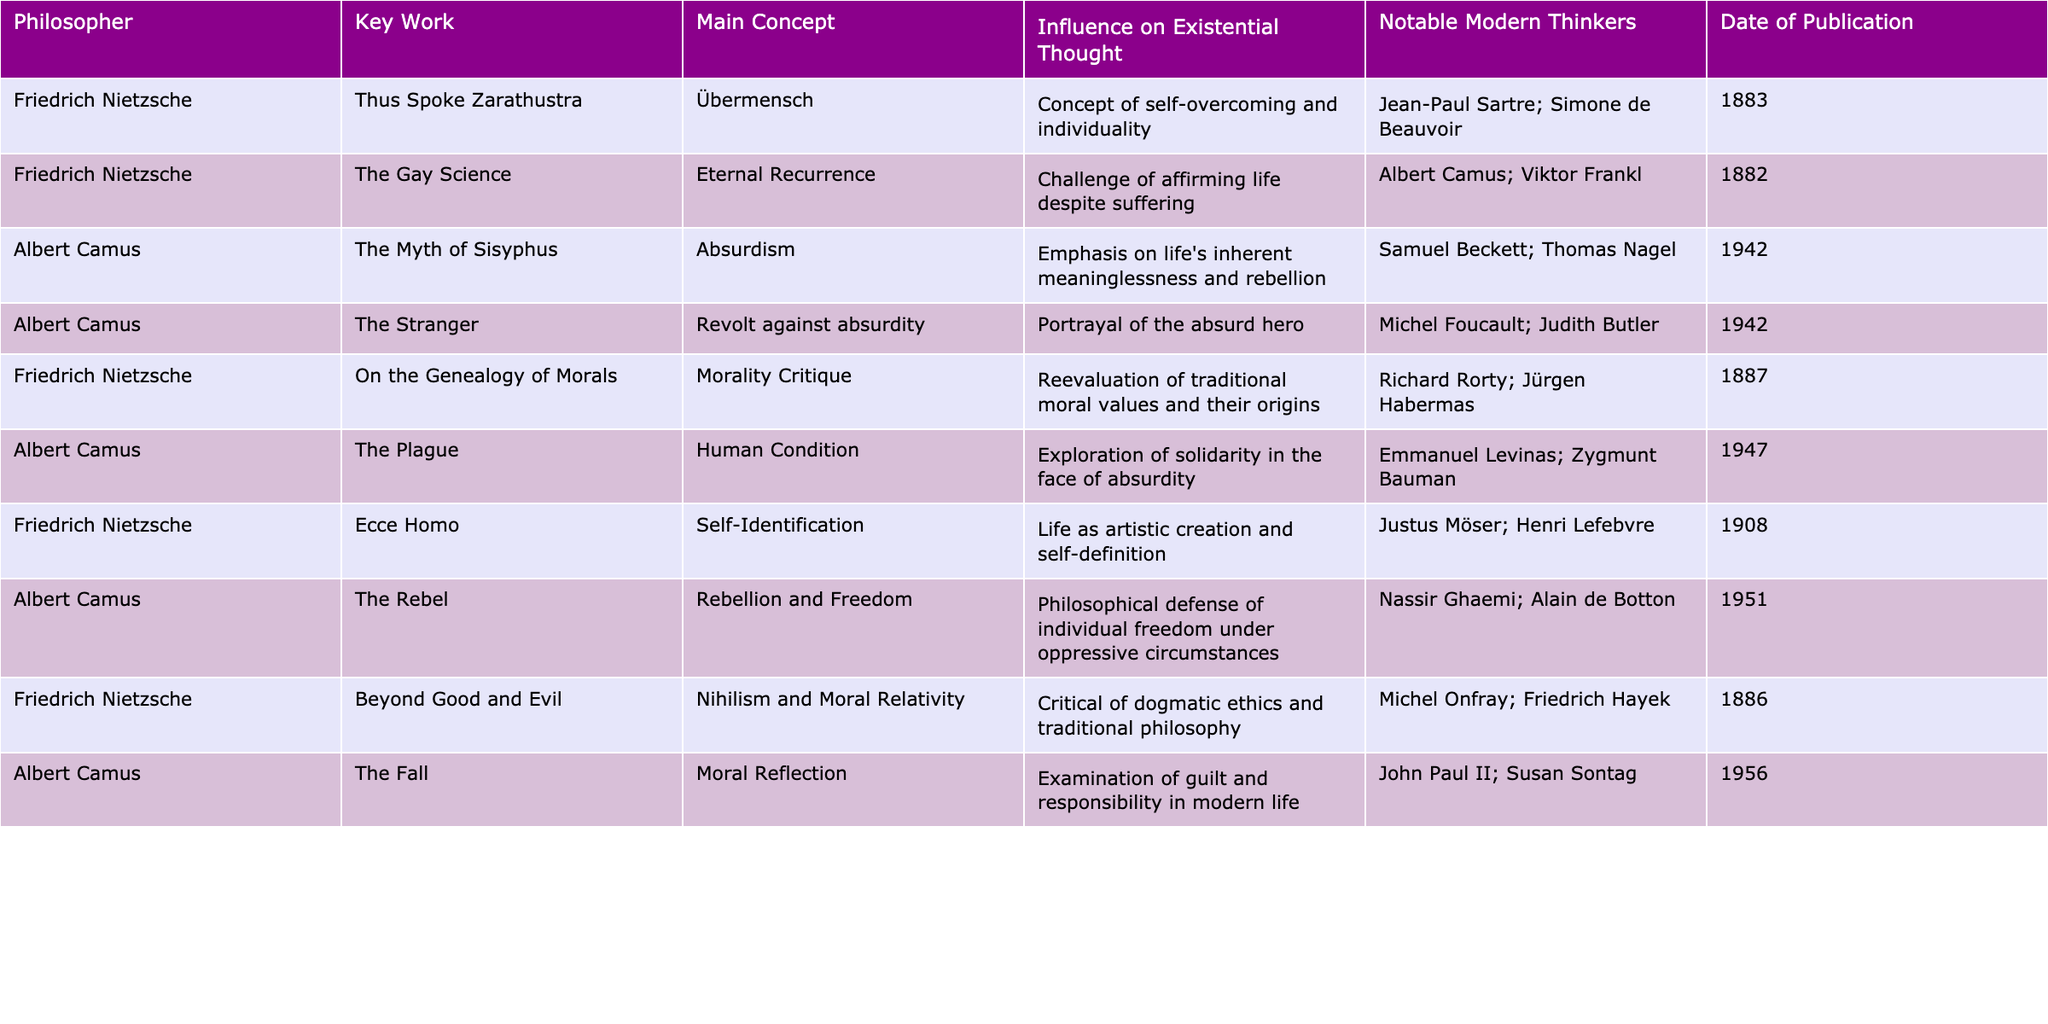What key work of Nietzsche discusses the concept of the Übermensch? According to the table, the key work of Nietzsche that discusses the concept of the Übermensch is "Thus Spoke Zarathustra."
Answer: Thus Spoke Zarathustra Which notable modern thinker is influenced by Nietzsche's concept of Eternal Recurrence? The table indicates that Albert Camus is a notable modern thinker influenced by Nietzsche's concept of Eternal Recurrence from "The Gay Science."
Answer: Albert Camus How many notable thinkers are associated with Camus' "The Myth of Sisyphus"? The table shows that Camus' "The Myth of Sisyphus" influences two notable modern thinkers: Samuel Beckett and Thomas Nagel.
Answer: 2 In which year was Nietzsche's "On the Genealogy of Morals" published? From the table, it can be seen that Nietzsche's "On the Genealogy of Morals" was published in 1887.
Answer: 1887 Which philosopher's works include themes of rebellion and freedom? The table states that Albert Camus' works, specifically "The Rebel," include themes of rebellion and freedom.
Answer: Albert Camus What are the main concepts of Camus' "The Stranger"? The table indicates that the main concept of Camus' "The Stranger" is the revolt against absurdity.
Answer: Revolt against absurdity Which philosopher's works are related to the exploration of the human condition in the face of absurdity? The table suggests that Albert Camus' "The Plague" explores the human condition in the face of absurdity.
Answer: Albert Camus Compare the number of notable modern thinkers influenced by Nietzsche and Camus. Nietzsche has four notable modern thinkers (Sartre, Beauvoir, Frankl, Onfray) compared to Camus’ five (Beckett, Nagel, Foucault, Butler, Ghaemi, and de Botton).
Answer: Camus has more thinkers Which work of Nietzsche is focused on the critique of morality? The table lists "On the Genealogy of Morals" as Nietzsche's work focused on the critique of morality.
Answer: On the Genealogy of Morals Identify the shared theme of the influence on existential thought between Nietzsche's "Beyond Good and Evil" and Camus' "The Myth of Sisyphus." Both Nietzsche's "Beyond Good and Evil" and Camus' "The Myth of Sisyphus" influence thinkers through challenges to traditional philosophical views, with Nietzsche focusing on nihilism and moral relativity, while Camus emphasizes life's inherent meaninglessness.
Answer: Challenges to traditional views What is the relationship between the publication dates of Nietzsche's and Camus' works listed in the table? There is a gap in the publication dates: Nietzsche's works range from 1882 to 1908, while Camus' works are published from 1942 to 1956, indicating that Camus' most influential works came decades later, showing a shift in existential thought.
Answer: Camus' works are later than Nietzsche's 